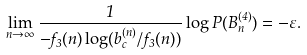Convert formula to latex. <formula><loc_0><loc_0><loc_500><loc_500>\lim _ { n \to \infty } \frac { 1 } { - f _ { 3 } ( n ) \log ( b _ { c } ^ { ( n ) } / f _ { 3 } ( n ) ) } \log P ( B _ { n } ^ { ( 4 ) } ) = - \varepsilon .</formula> 